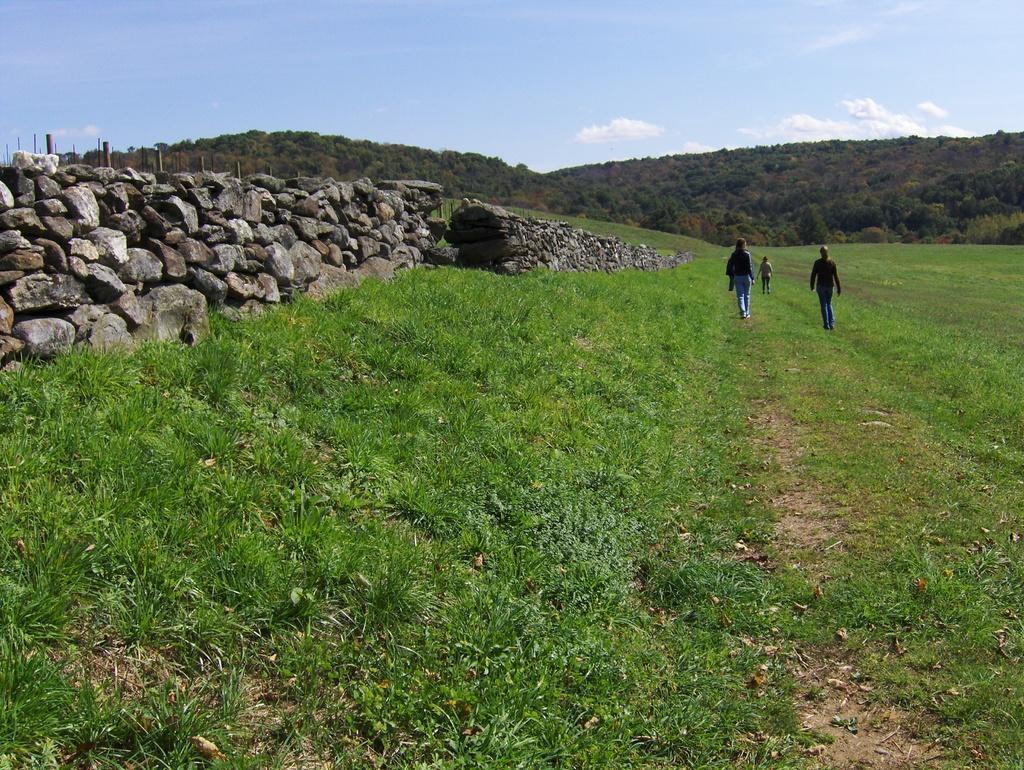How would you summarize this image in a sentence or two? It is a beautiful scenery, there is a huge land covered with a lot of grass and three people are walking on the grass, to their left side there is a wall build up of stones and in the background there are two mountains. 